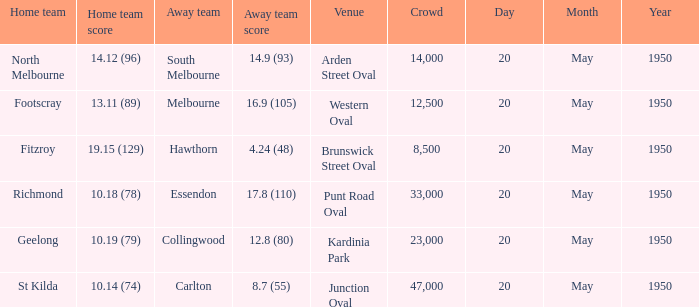At which game with a 17.8 (110) score for the away team was the largest audience present? 33000.0. 